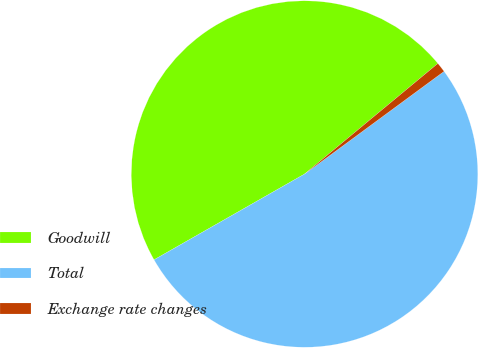Convert chart to OTSL. <chart><loc_0><loc_0><loc_500><loc_500><pie_chart><fcel>Goodwill<fcel>Total<fcel>Exchange rate changes<nl><fcel>47.23%<fcel>51.86%<fcel>0.92%<nl></chart> 